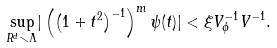<formula> <loc_0><loc_0><loc_500><loc_500>\underset { R ^ { d } \smallsetminus \Lambda } { \sup } | \left ( \left ( 1 + t ^ { 2 } \right ) ^ { - 1 } \right ) ^ { m } \psi ( t ) | < \xi V _ { \phi } ^ { - 1 } V ^ { - 1 } .</formula> 